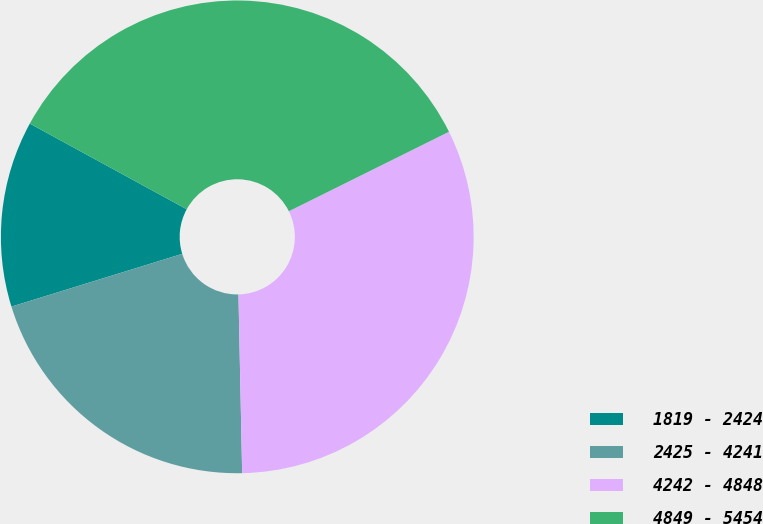Convert chart. <chart><loc_0><loc_0><loc_500><loc_500><pie_chart><fcel>1819 - 2424<fcel>2425 - 4241<fcel>4242 - 4848<fcel>4849 - 5454<nl><fcel>12.72%<fcel>20.56%<fcel>32.0%<fcel>34.71%<nl></chart> 